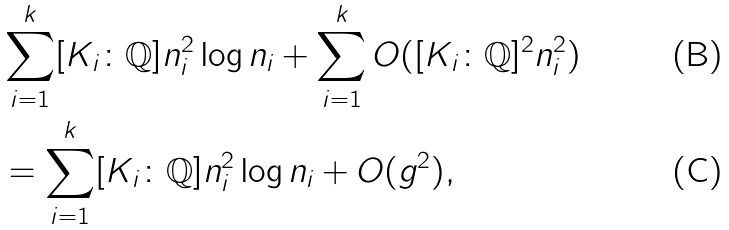<formula> <loc_0><loc_0><loc_500><loc_500>& \sum _ { i = 1 } ^ { k } [ K _ { i } \colon \mathbb { Q } ] n _ { i } ^ { 2 } \log n _ { i } + \sum _ { i = 1 } ^ { k } O ( [ K _ { i } \colon \mathbb { Q } ] ^ { 2 } n _ { i } ^ { 2 } ) \\ & = \sum _ { i = 1 } ^ { k } [ K _ { i } \colon \mathbb { Q } ] n _ { i } ^ { 2 } \log n _ { i } + O ( g ^ { 2 } ) ,</formula> 